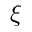Convert formula to latex. <formula><loc_0><loc_0><loc_500><loc_500>\xi</formula> 